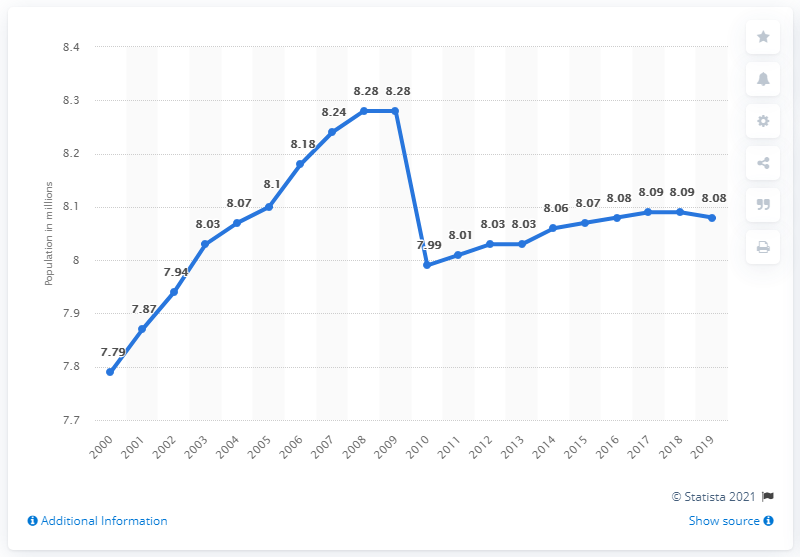Point out several critical features in this image. In 2019, approximately 8.08 million U.S. residents lived in group quarters. 